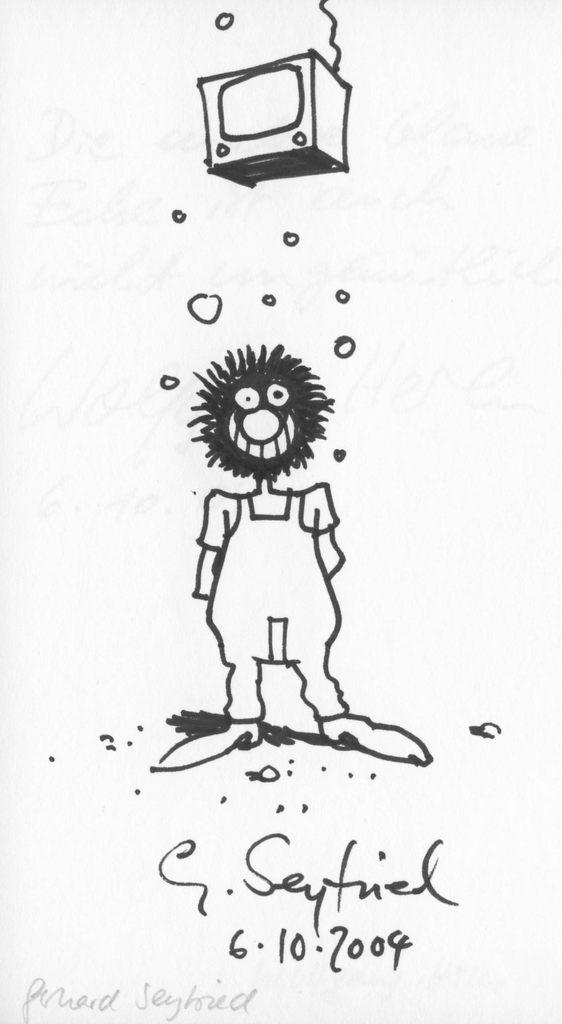What is depicted in the sketch in the image? There is a sketch of a person standing in the image. What electronic device is visible at the top of the image? There is a television at the top of the image. What type of information is provided at the bottom of the image? There is text at the bottom of the image. What color is the background of the image? The background of the image is white. What type of rock can be seen in the image? There is no rock present in the image. How does the person in the sketch stop the television in the image? The person in the sketch is not interacting with the television, and there is no indication of stopping it in the image. 